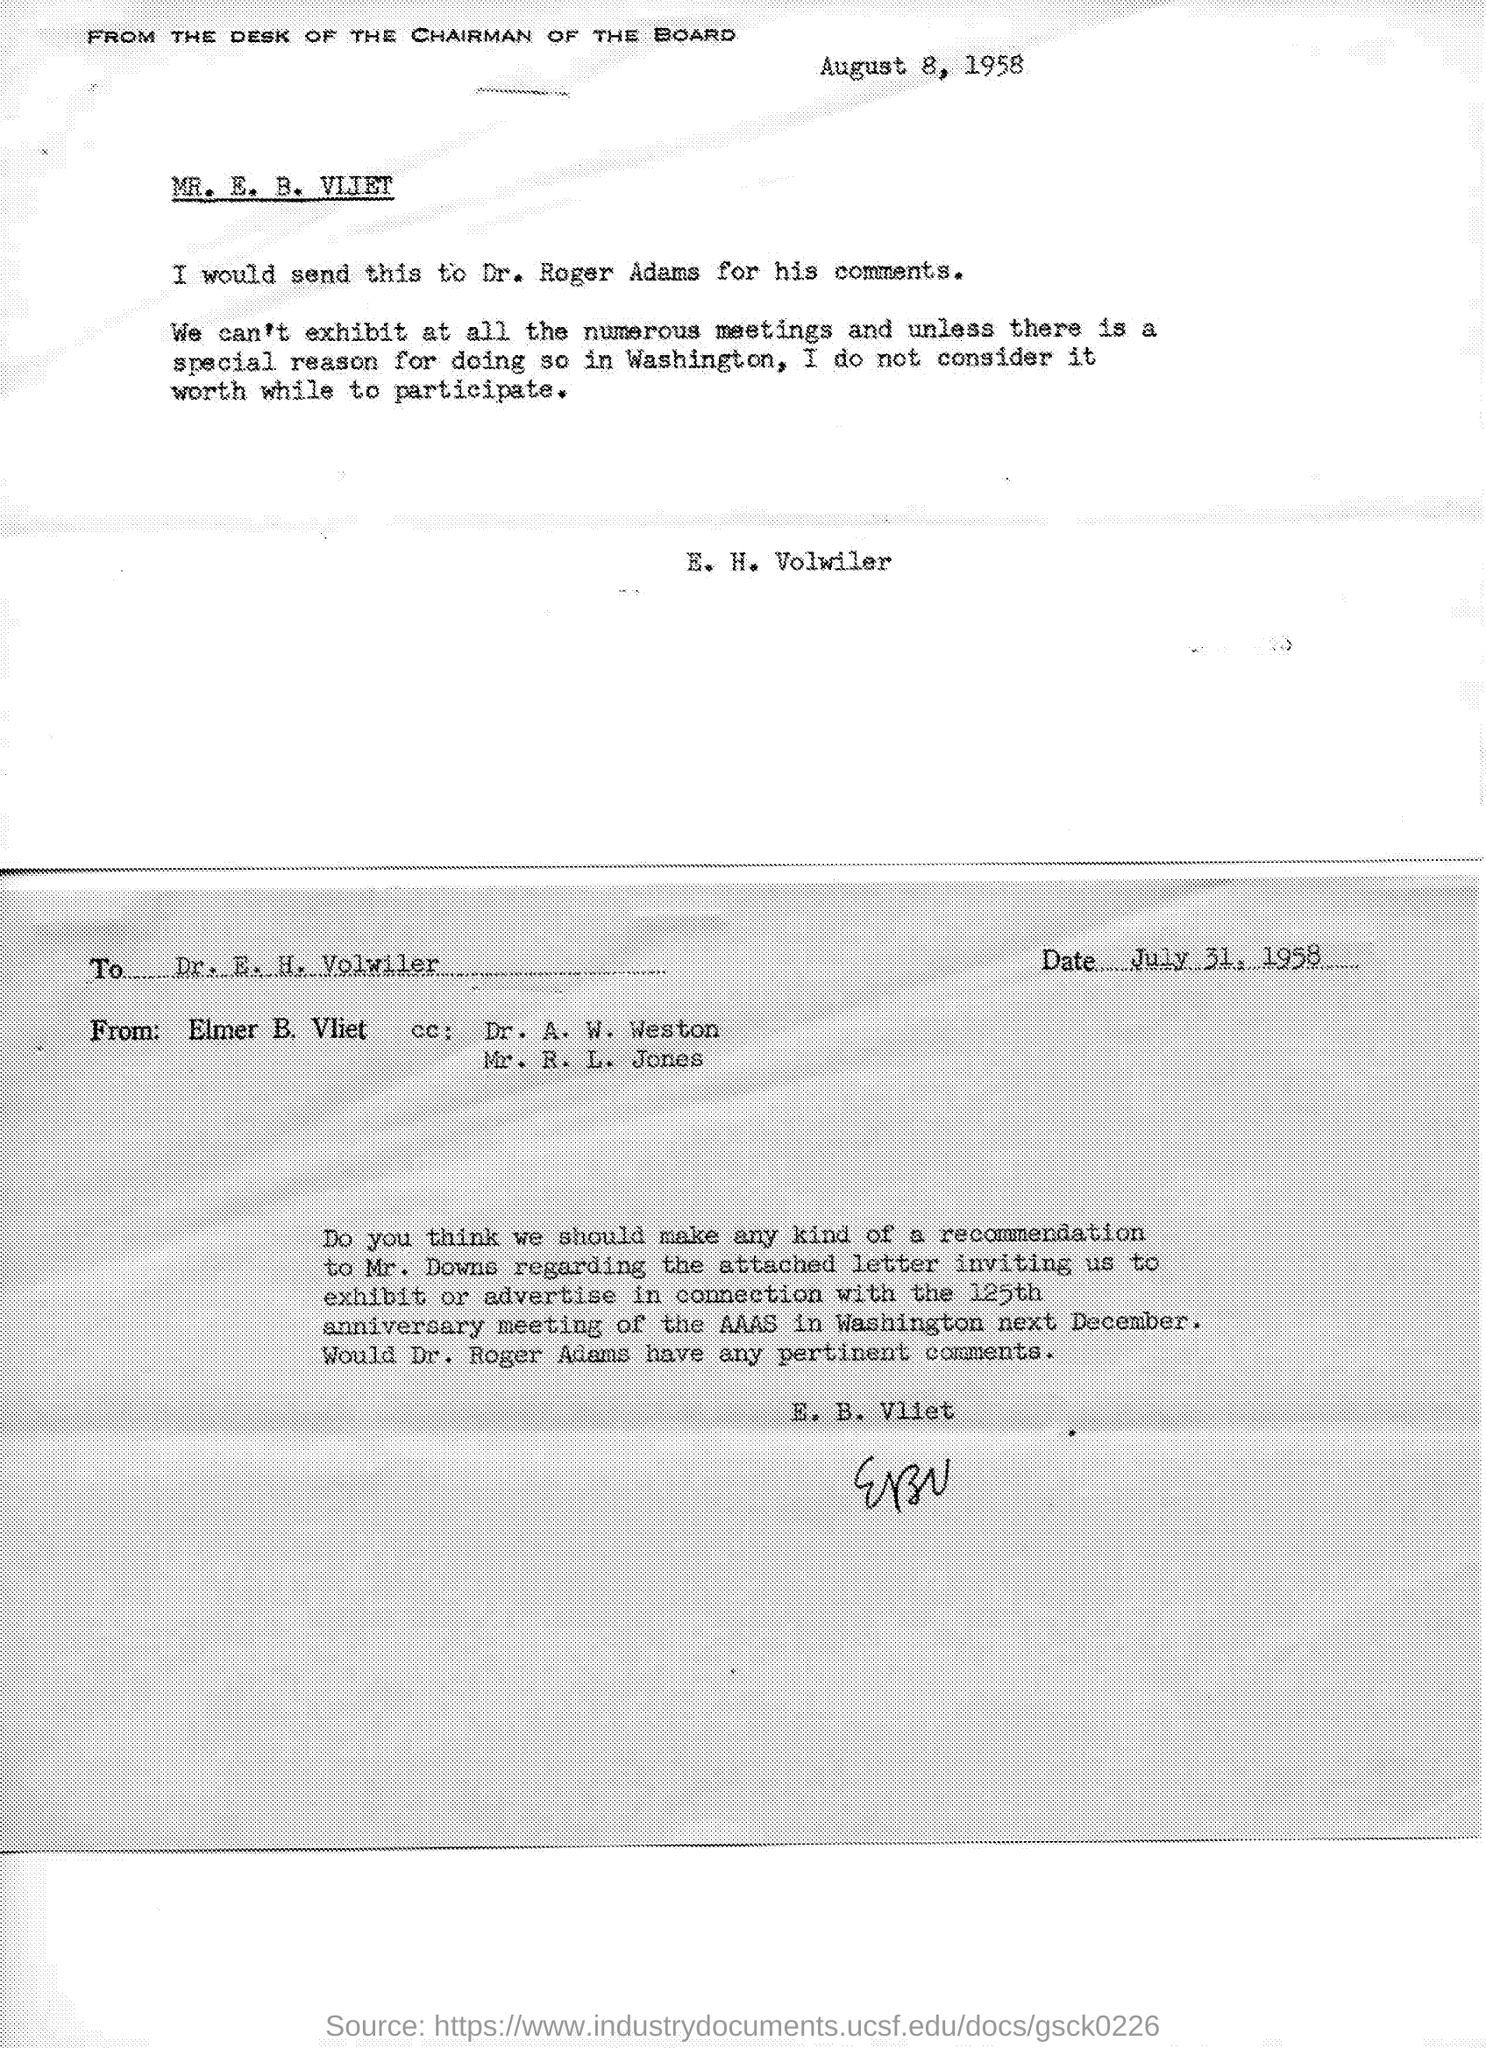List a handful of essential elements in this visual. The date on the document is August 8, 1958. 